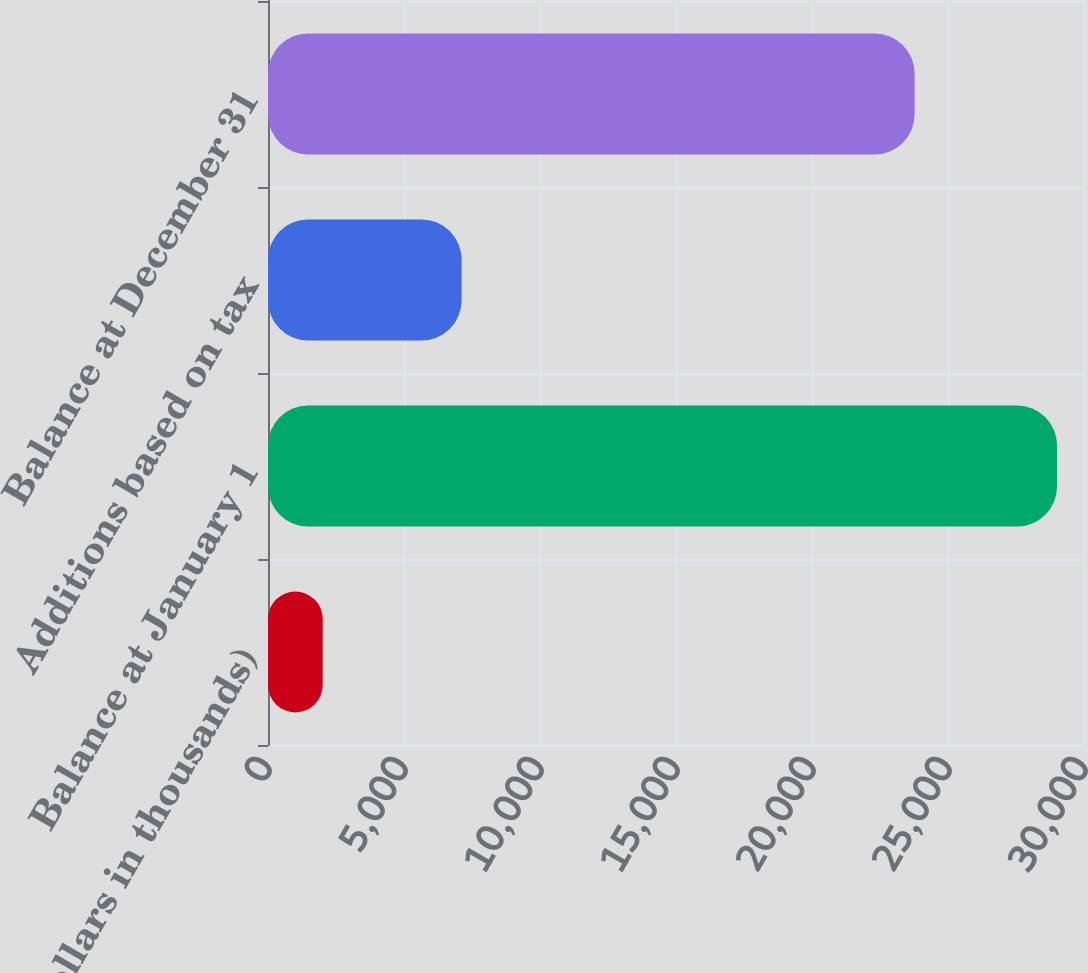<chart> <loc_0><loc_0><loc_500><loc_500><bar_chart><fcel>(Dollars in thousands)<fcel>Balance at January 1<fcel>Additions based on tax<fcel>Balance at December 31<nl><fcel>2010<fcel>29010<fcel>7119<fcel>23773<nl></chart> 